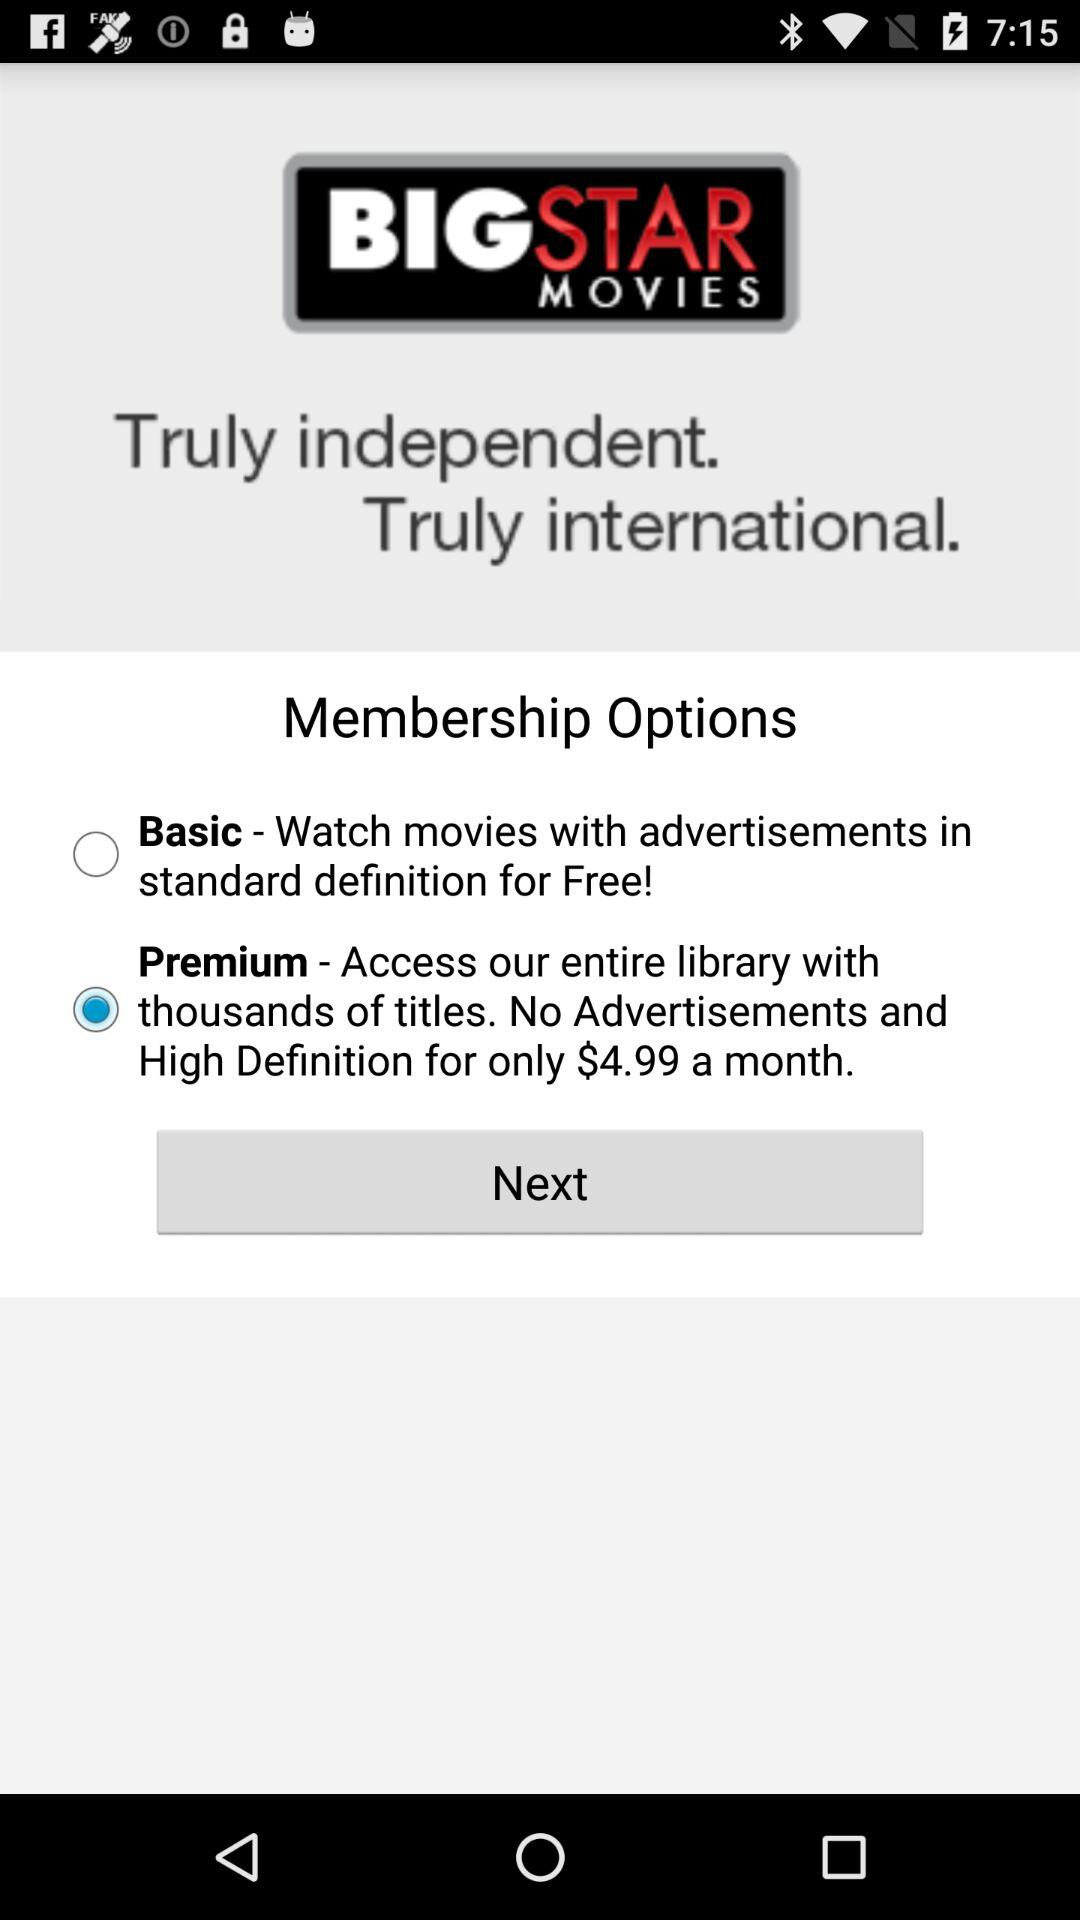What benefits does the Premium membership offer? The Premium membership offers an ad-free experience with access to the entire library of titles in high definition. It is available for $4.99 a month, providing a more elevated viewing experience compared to the Basic option. Is there a free membership option available as well? Yes, there is a Basic membership option which is free of cost. This option allows you to watch movies with advertisements in standard definition. 